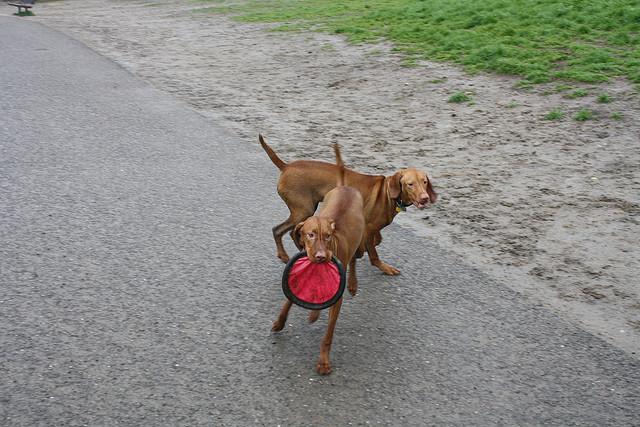What does the dog have in his mouth?
Quick response, please. Frisbee. Do the dogs appear to be the same breed?
Be succinct. Yes. What plant is shown?
Be succinct. Grass. Is the dog walking?
Write a very short answer. Yes. 